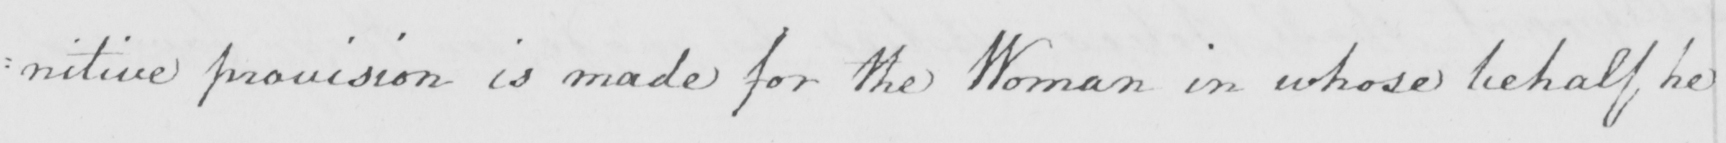Transcribe the text shown in this historical manuscript line. : nitive provision is made for the Woman on whose behalf he 